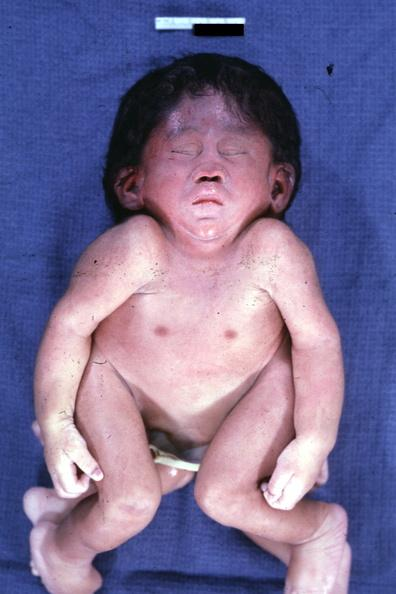s this the best photo to illustrate this case externally?
Answer the question using a single word or phrase. Yes 